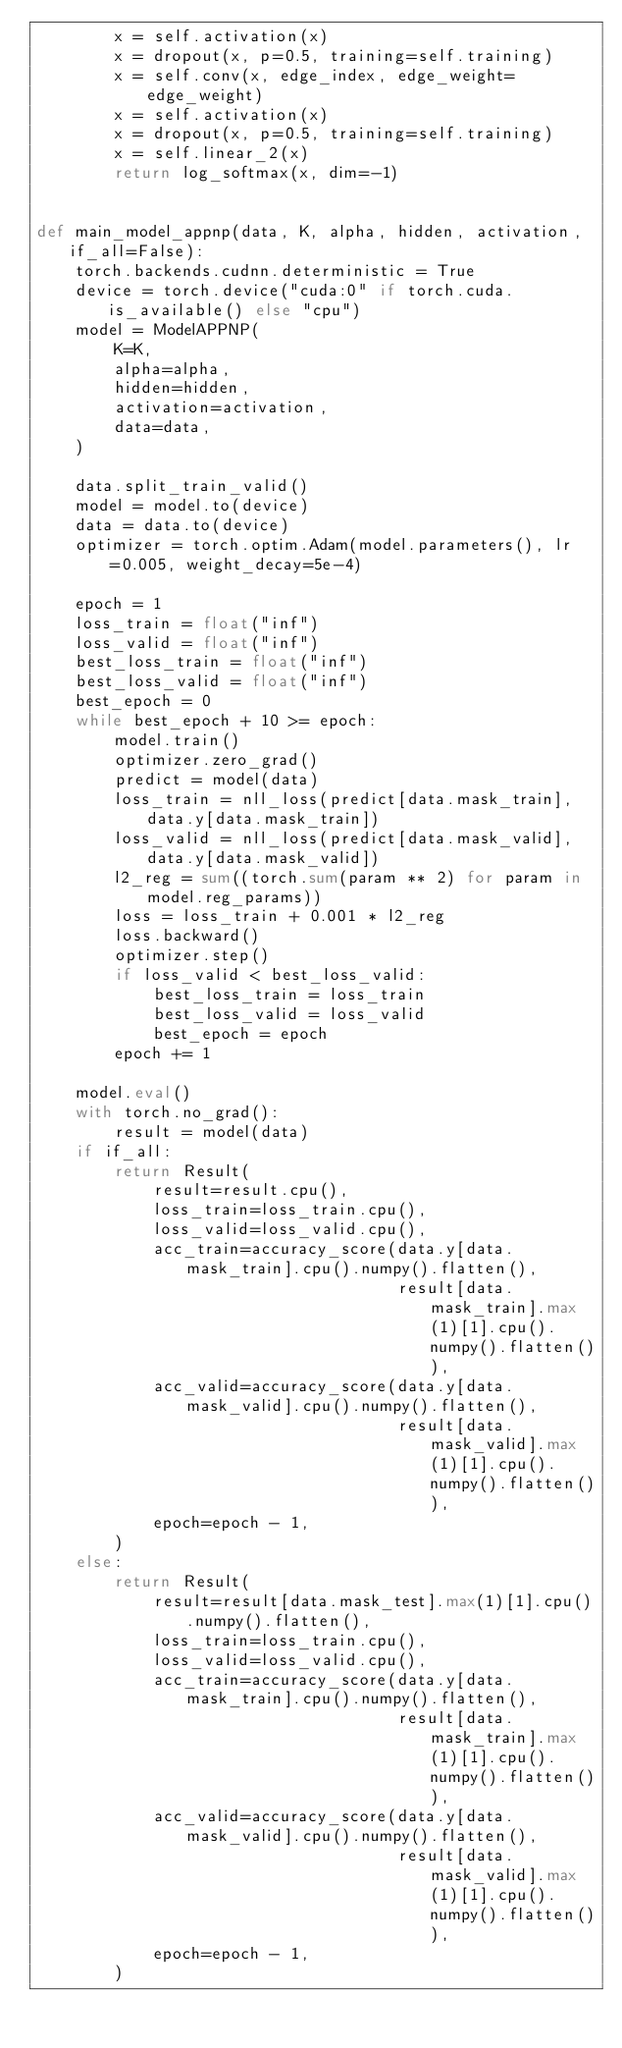Convert code to text. <code><loc_0><loc_0><loc_500><loc_500><_Python_>        x = self.activation(x)
        x = dropout(x, p=0.5, training=self.training)
        x = self.conv(x, edge_index, edge_weight=edge_weight)
        x = self.activation(x)
        x = dropout(x, p=0.5, training=self.training)
        x = self.linear_2(x)
        return log_softmax(x, dim=-1)


def main_model_appnp(data, K, alpha, hidden, activation, if_all=False):
    torch.backends.cudnn.deterministic = True
    device = torch.device("cuda:0" if torch.cuda.is_available() else "cpu")
    model = ModelAPPNP(
        K=K,
        alpha=alpha,
        hidden=hidden,
        activation=activation,
        data=data,
    )

    data.split_train_valid()
    model = model.to(device)
    data = data.to(device)
    optimizer = torch.optim.Adam(model.parameters(), lr=0.005, weight_decay=5e-4)

    epoch = 1
    loss_train = float("inf")
    loss_valid = float("inf")
    best_loss_train = float("inf")
    best_loss_valid = float("inf")
    best_epoch = 0
    while best_epoch + 10 >= epoch:
        model.train()
        optimizer.zero_grad()
        predict = model(data)
        loss_train = nll_loss(predict[data.mask_train], data.y[data.mask_train])
        loss_valid = nll_loss(predict[data.mask_valid], data.y[data.mask_valid])
        l2_reg = sum((torch.sum(param ** 2) for param in model.reg_params))
        loss = loss_train + 0.001 * l2_reg
        loss.backward()
        optimizer.step()
        if loss_valid < best_loss_valid:
            best_loss_train = loss_train
            best_loss_valid = loss_valid
            best_epoch = epoch
        epoch += 1

    model.eval()
    with torch.no_grad():
        result = model(data)
    if if_all:
        return Result(
            result=result.cpu(),
            loss_train=loss_train.cpu(),
            loss_valid=loss_valid.cpu(),
            acc_train=accuracy_score(data.y[data.mask_train].cpu().numpy().flatten(),
                                     result[data.mask_train].max(1)[1].cpu().numpy().flatten()),
            acc_valid=accuracy_score(data.y[data.mask_valid].cpu().numpy().flatten(),
                                     result[data.mask_valid].max(1)[1].cpu().numpy().flatten()),
            epoch=epoch - 1,
        )
    else:
        return Result(
            result=result[data.mask_test].max(1)[1].cpu().numpy().flatten(),
            loss_train=loss_train.cpu(),
            loss_valid=loss_valid.cpu(),
            acc_train=accuracy_score(data.y[data.mask_train].cpu().numpy().flatten(),
                                     result[data.mask_train].max(1)[1].cpu().numpy().flatten()),
            acc_valid=accuracy_score(data.y[data.mask_valid].cpu().numpy().flatten(),
                                     result[data.mask_valid].max(1)[1].cpu().numpy().flatten()),
            epoch=epoch - 1,
        )
</code> 